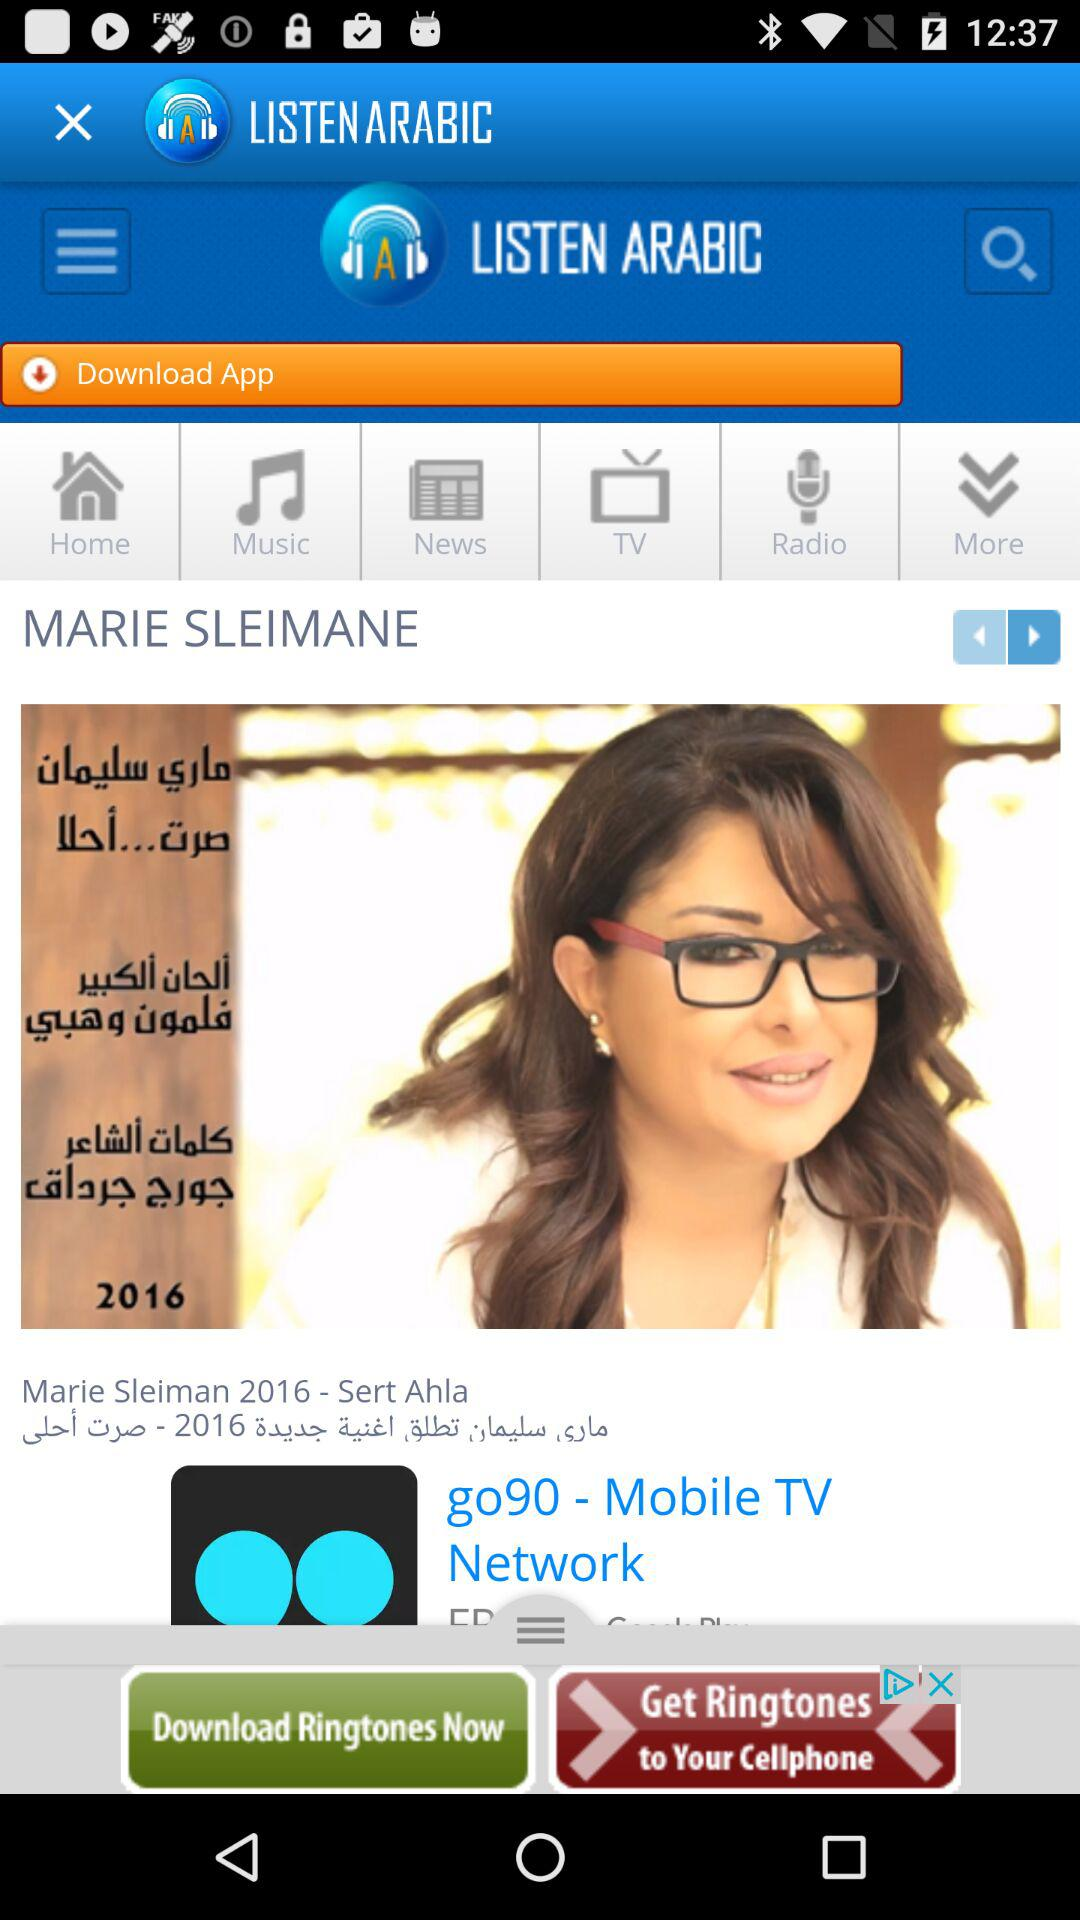What is the name of the artist that is currently playing?
Answer the question using a single word or phrase. Marie Sleiman 